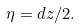Convert formula to latex. <formula><loc_0><loc_0><loc_500><loc_500>\eta = d z / 2 .</formula> 